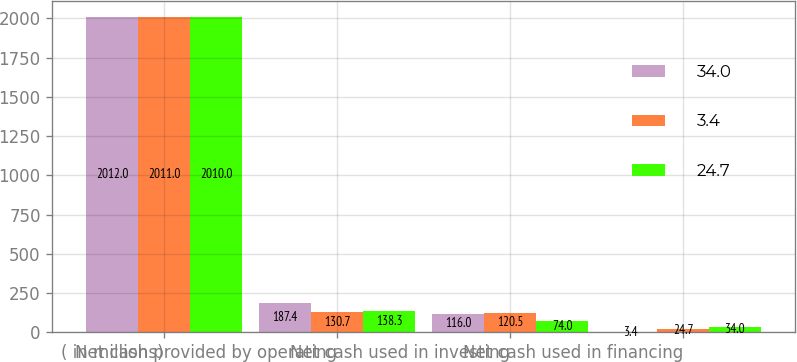Convert chart. <chart><loc_0><loc_0><loc_500><loc_500><stacked_bar_chart><ecel><fcel>( in millions)<fcel>Net cash provided by operating<fcel>Net cash used in investing<fcel>Net cash used in financing<nl><fcel>34<fcel>2012<fcel>187.4<fcel>116<fcel>3.4<nl><fcel>3.4<fcel>2011<fcel>130.7<fcel>120.5<fcel>24.7<nl><fcel>24.7<fcel>2010<fcel>138.3<fcel>74<fcel>34<nl></chart> 